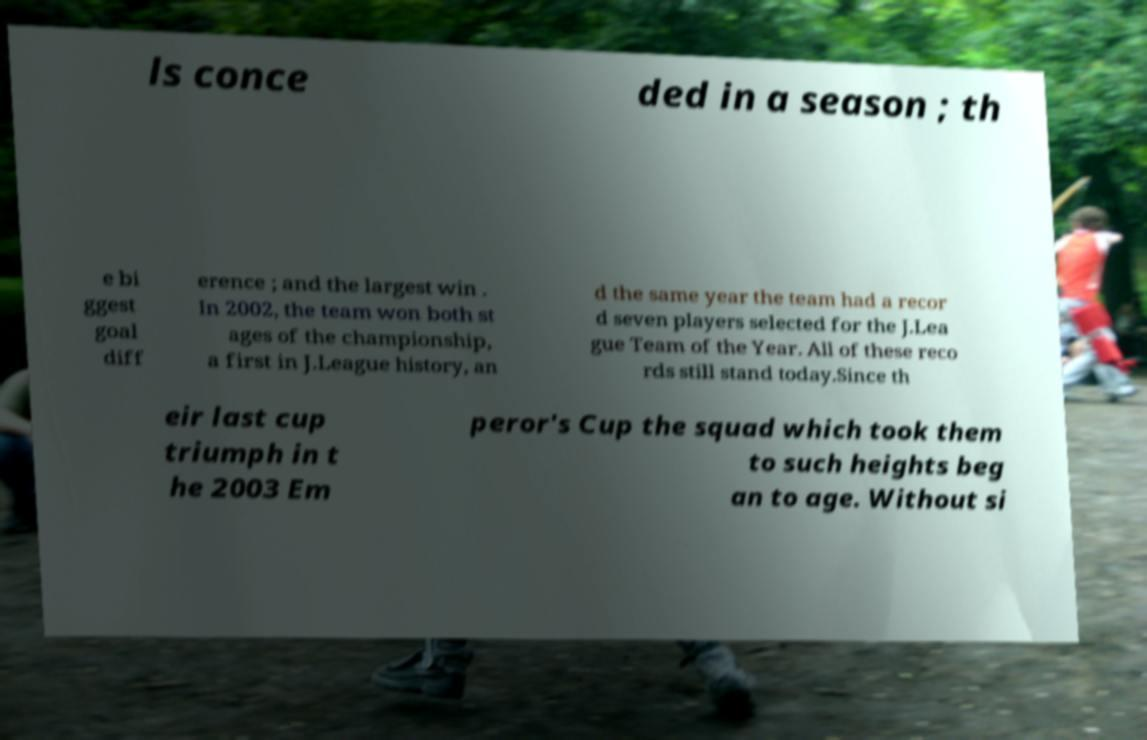Can you read and provide the text displayed in the image?This photo seems to have some interesting text. Can you extract and type it out for me? ls conce ded in a season ; th e bi ggest goal diff erence ; and the largest win . In 2002, the team won both st ages of the championship, a first in J.League history, an d the same year the team had a recor d seven players selected for the J.Lea gue Team of the Year. All of these reco rds still stand today.Since th eir last cup triumph in t he 2003 Em peror's Cup the squad which took them to such heights beg an to age. Without si 